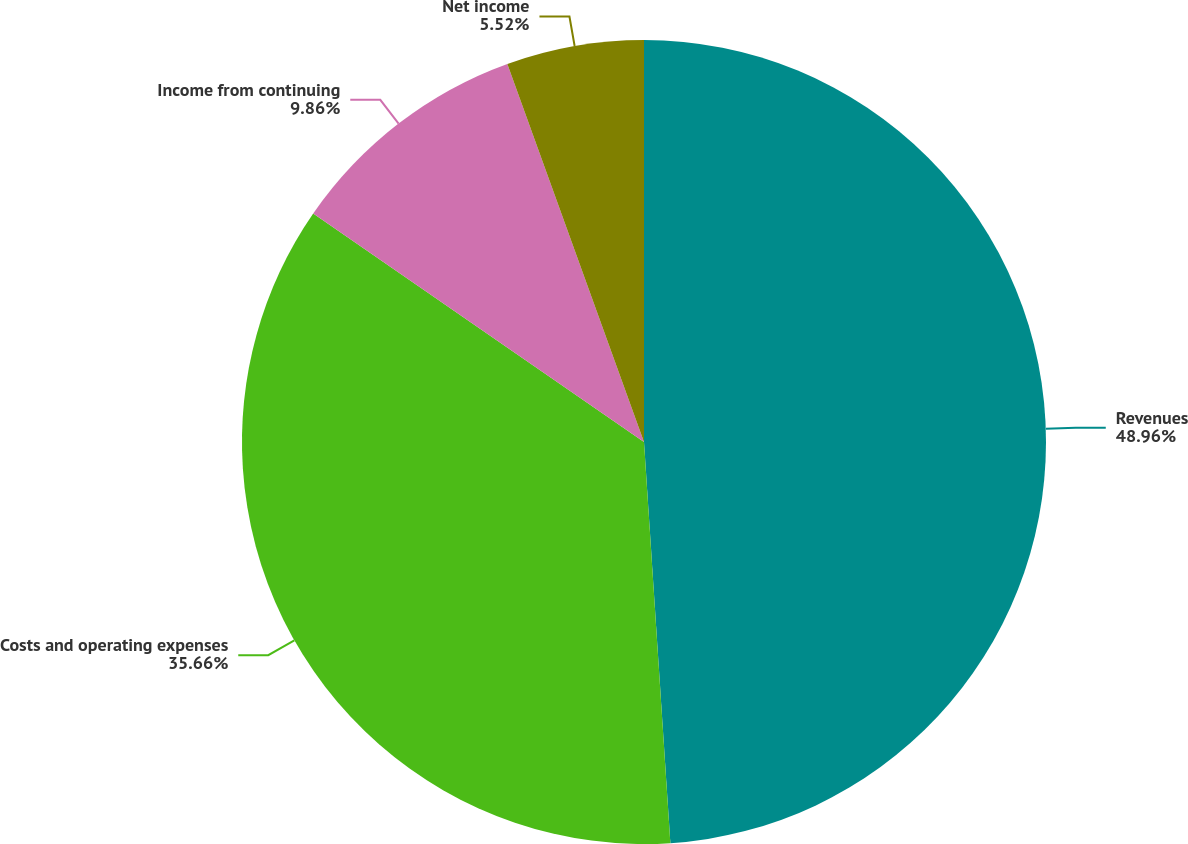Convert chart to OTSL. <chart><loc_0><loc_0><loc_500><loc_500><pie_chart><fcel>Revenues<fcel>Costs and operating expenses<fcel>Income from continuing<fcel>Net income<nl><fcel>48.95%<fcel>35.66%<fcel>9.86%<fcel>5.52%<nl></chart> 